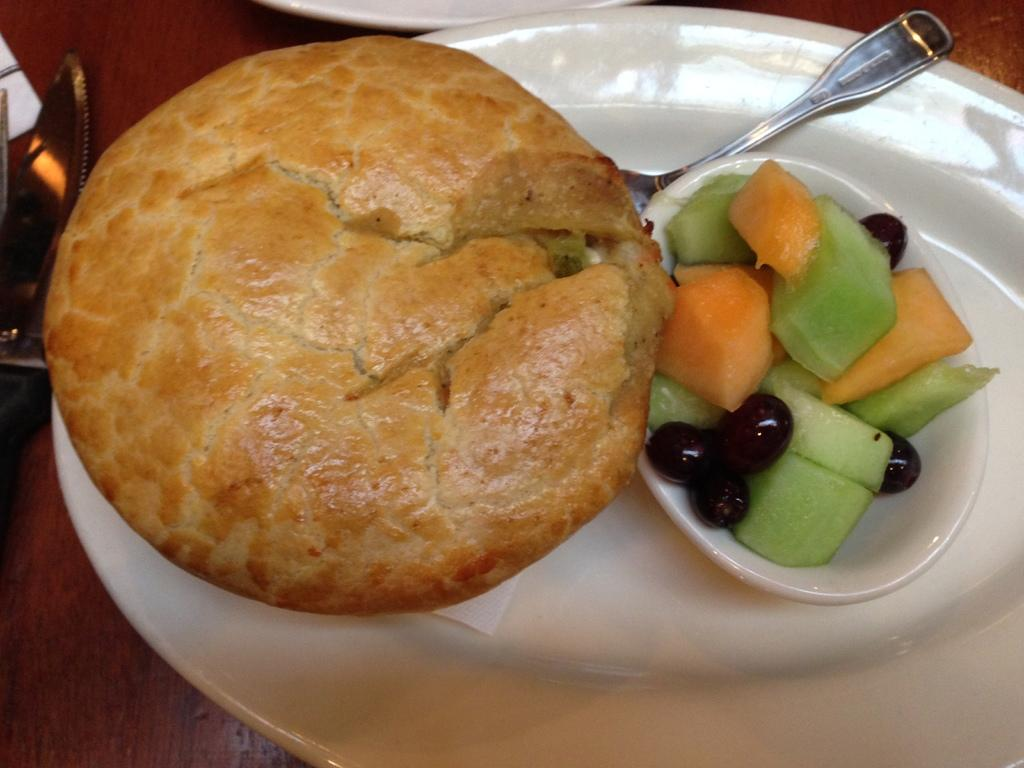What piece of furniture is present in the image? There is a table in the image. What is placed on the table? There is a plate on the table. What utensil is on the plate? There is a spoon on the plate. What can be found on the plate along with the spoon? There are food items on the plate. What type of ink is used to write on the plate in the image? There is no ink or writing present on the plate in the image. 